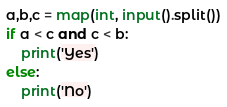Convert code to text. <code><loc_0><loc_0><loc_500><loc_500><_Python_>a,b,c = map(int, input().split())
if a < c and c < b:
    print('Yes')
else:
    print('No')</code> 